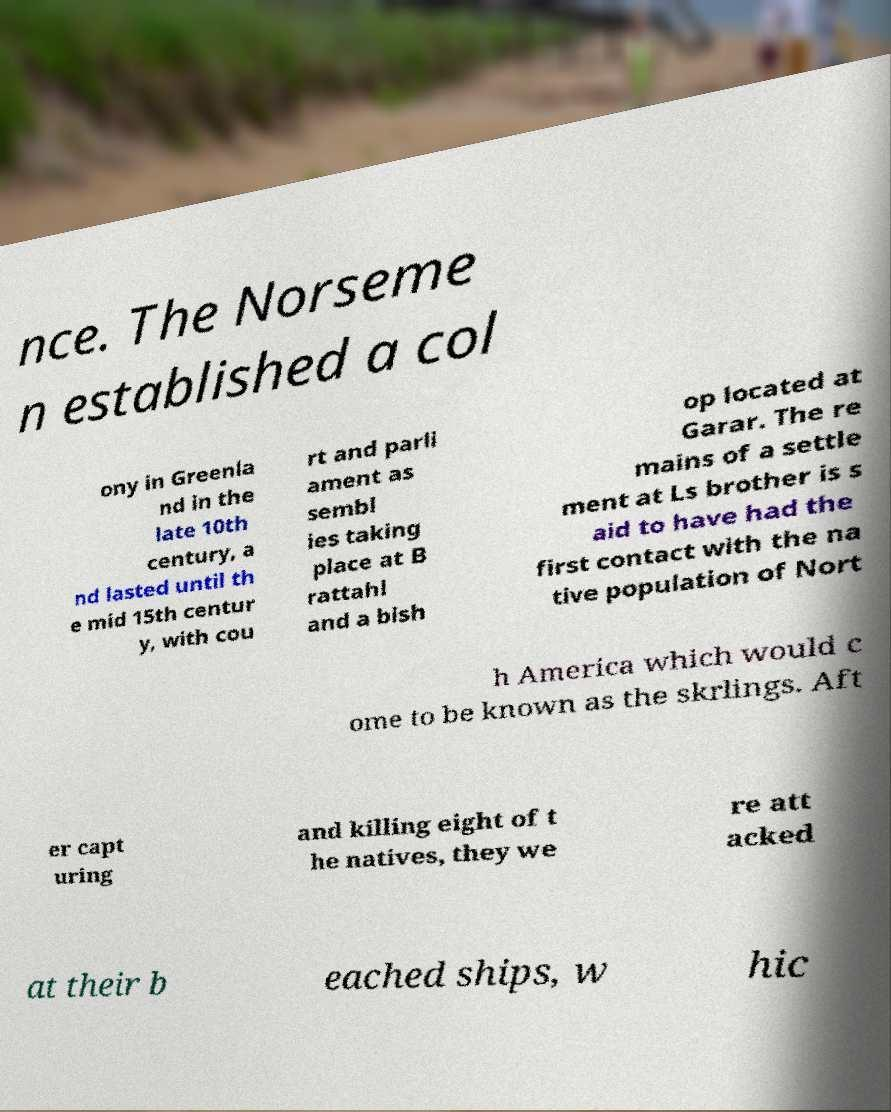Please identify and transcribe the text found in this image. nce. The Norseme n established a col ony in Greenla nd in the late 10th century, a nd lasted until th e mid 15th centur y, with cou rt and parli ament as sembl ies taking place at B rattahl and a bish op located at Garar. The re mains of a settle ment at Ls brother is s aid to have had the first contact with the na tive population of Nort h America which would c ome to be known as the skrlings. Aft er capt uring and killing eight of t he natives, they we re att acked at their b eached ships, w hic 